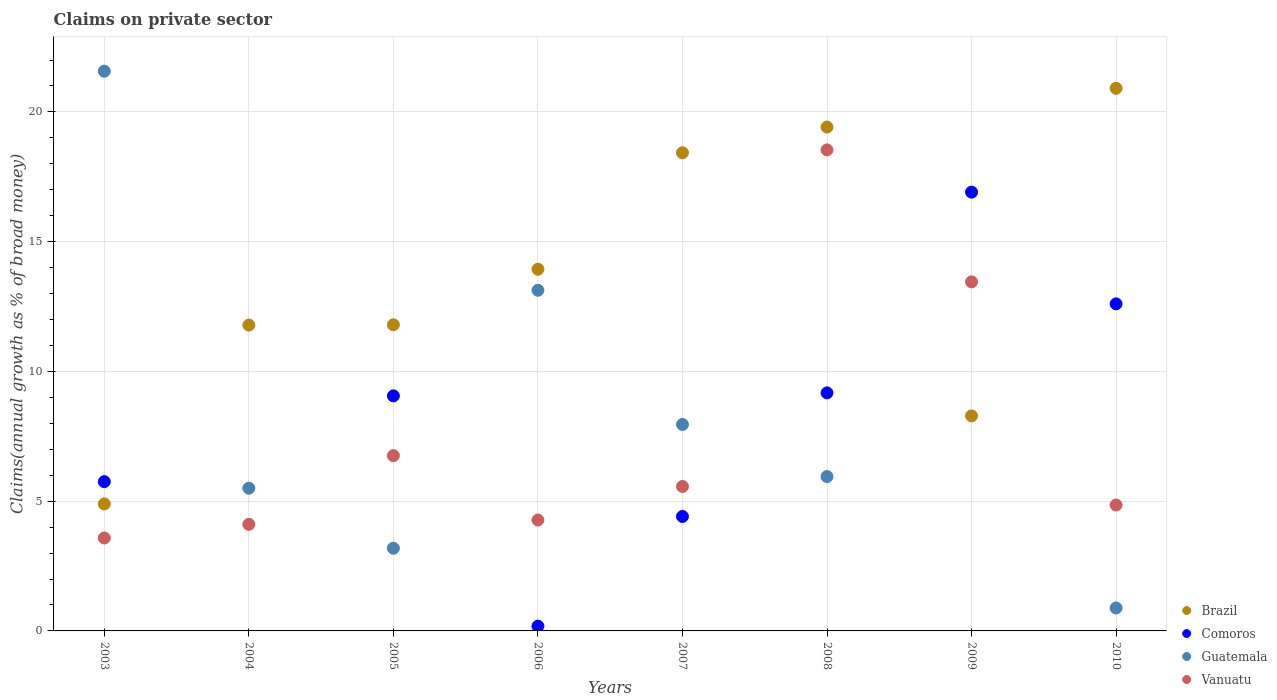Across all years, what is the maximum percentage of broad money claimed on private sector in Comoros?
Ensure brevity in your answer.  16.91. In which year was the percentage of broad money claimed on private sector in Brazil maximum?
Give a very brief answer. 2010. What is the total percentage of broad money claimed on private sector in Comoros in the graph?
Offer a very short reply. 58.09. What is the difference between the percentage of broad money claimed on private sector in Vanuatu in 2005 and that in 2009?
Your response must be concise. -6.7. What is the difference between the percentage of broad money claimed on private sector in Guatemala in 2004 and the percentage of broad money claimed on private sector in Vanuatu in 2009?
Provide a short and direct response. -7.95. What is the average percentage of broad money claimed on private sector in Comoros per year?
Offer a terse response. 7.26. In the year 2003, what is the difference between the percentage of broad money claimed on private sector in Guatemala and percentage of broad money claimed on private sector in Comoros?
Your response must be concise. 15.82. What is the ratio of the percentage of broad money claimed on private sector in Brazil in 2003 to that in 2006?
Make the answer very short. 0.35. What is the difference between the highest and the second highest percentage of broad money claimed on private sector in Comoros?
Provide a short and direct response. 4.3. What is the difference between the highest and the lowest percentage of broad money claimed on private sector in Guatemala?
Your answer should be compact. 21.57. In how many years, is the percentage of broad money claimed on private sector in Guatemala greater than the average percentage of broad money claimed on private sector in Guatemala taken over all years?
Your response must be concise. 3. Is the sum of the percentage of broad money claimed on private sector in Guatemala in 2007 and 2008 greater than the maximum percentage of broad money claimed on private sector in Vanuatu across all years?
Provide a succinct answer. No. Is it the case that in every year, the sum of the percentage of broad money claimed on private sector in Vanuatu and percentage of broad money claimed on private sector in Comoros  is greater than the sum of percentage of broad money claimed on private sector in Guatemala and percentage of broad money claimed on private sector in Brazil?
Offer a very short reply. No. Is it the case that in every year, the sum of the percentage of broad money claimed on private sector in Brazil and percentage of broad money claimed on private sector in Guatemala  is greater than the percentage of broad money claimed on private sector in Comoros?
Offer a terse response. No. Does the percentage of broad money claimed on private sector in Comoros monotonically increase over the years?
Keep it short and to the point. No. Is the percentage of broad money claimed on private sector in Brazil strictly less than the percentage of broad money claimed on private sector in Comoros over the years?
Your answer should be very brief. No. Are the values on the major ticks of Y-axis written in scientific E-notation?
Your answer should be compact. No. How many legend labels are there?
Offer a very short reply. 4. How are the legend labels stacked?
Your answer should be very brief. Vertical. What is the title of the graph?
Offer a terse response. Claims on private sector. Does "Netherlands" appear as one of the legend labels in the graph?
Your answer should be very brief. No. What is the label or title of the Y-axis?
Provide a short and direct response. Claims(annual growth as % of broad money). What is the Claims(annual growth as % of broad money) in Brazil in 2003?
Your answer should be compact. 4.89. What is the Claims(annual growth as % of broad money) of Comoros in 2003?
Offer a terse response. 5.75. What is the Claims(annual growth as % of broad money) of Guatemala in 2003?
Give a very brief answer. 21.57. What is the Claims(annual growth as % of broad money) of Vanuatu in 2003?
Provide a succinct answer. 3.58. What is the Claims(annual growth as % of broad money) of Brazil in 2004?
Your answer should be very brief. 11.79. What is the Claims(annual growth as % of broad money) of Comoros in 2004?
Make the answer very short. 0. What is the Claims(annual growth as % of broad money) in Guatemala in 2004?
Give a very brief answer. 5.5. What is the Claims(annual growth as % of broad money) of Vanuatu in 2004?
Give a very brief answer. 4.11. What is the Claims(annual growth as % of broad money) in Brazil in 2005?
Provide a short and direct response. 11.8. What is the Claims(annual growth as % of broad money) of Comoros in 2005?
Offer a terse response. 9.06. What is the Claims(annual growth as % of broad money) in Guatemala in 2005?
Your response must be concise. 3.19. What is the Claims(annual growth as % of broad money) in Vanuatu in 2005?
Your response must be concise. 6.75. What is the Claims(annual growth as % of broad money) of Brazil in 2006?
Provide a succinct answer. 13.94. What is the Claims(annual growth as % of broad money) in Comoros in 2006?
Your response must be concise. 0.18. What is the Claims(annual growth as % of broad money) of Guatemala in 2006?
Offer a terse response. 13.13. What is the Claims(annual growth as % of broad money) in Vanuatu in 2006?
Keep it short and to the point. 4.27. What is the Claims(annual growth as % of broad money) in Brazil in 2007?
Provide a short and direct response. 18.43. What is the Claims(annual growth as % of broad money) of Comoros in 2007?
Make the answer very short. 4.41. What is the Claims(annual growth as % of broad money) of Guatemala in 2007?
Provide a short and direct response. 7.96. What is the Claims(annual growth as % of broad money) of Vanuatu in 2007?
Ensure brevity in your answer.  5.57. What is the Claims(annual growth as % of broad money) in Brazil in 2008?
Your response must be concise. 19.42. What is the Claims(annual growth as % of broad money) of Comoros in 2008?
Your answer should be very brief. 9.17. What is the Claims(annual growth as % of broad money) in Guatemala in 2008?
Your answer should be compact. 5.95. What is the Claims(annual growth as % of broad money) of Vanuatu in 2008?
Give a very brief answer. 18.54. What is the Claims(annual growth as % of broad money) in Brazil in 2009?
Keep it short and to the point. 8.29. What is the Claims(annual growth as % of broad money) of Comoros in 2009?
Keep it short and to the point. 16.91. What is the Claims(annual growth as % of broad money) in Vanuatu in 2009?
Your answer should be compact. 13.45. What is the Claims(annual growth as % of broad money) of Brazil in 2010?
Make the answer very short. 20.91. What is the Claims(annual growth as % of broad money) of Comoros in 2010?
Keep it short and to the point. 12.6. What is the Claims(annual growth as % of broad money) of Guatemala in 2010?
Offer a very short reply. 0.88. What is the Claims(annual growth as % of broad money) in Vanuatu in 2010?
Your answer should be compact. 4.85. Across all years, what is the maximum Claims(annual growth as % of broad money) of Brazil?
Your response must be concise. 20.91. Across all years, what is the maximum Claims(annual growth as % of broad money) of Comoros?
Make the answer very short. 16.91. Across all years, what is the maximum Claims(annual growth as % of broad money) of Guatemala?
Keep it short and to the point. 21.57. Across all years, what is the maximum Claims(annual growth as % of broad money) of Vanuatu?
Ensure brevity in your answer.  18.54. Across all years, what is the minimum Claims(annual growth as % of broad money) of Brazil?
Give a very brief answer. 4.89. Across all years, what is the minimum Claims(annual growth as % of broad money) in Vanuatu?
Offer a terse response. 3.58. What is the total Claims(annual growth as % of broad money) of Brazil in the graph?
Your answer should be very brief. 109.45. What is the total Claims(annual growth as % of broad money) in Comoros in the graph?
Your answer should be compact. 58.09. What is the total Claims(annual growth as % of broad money) in Guatemala in the graph?
Offer a very short reply. 58.17. What is the total Claims(annual growth as % of broad money) of Vanuatu in the graph?
Ensure brevity in your answer.  61.12. What is the difference between the Claims(annual growth as % of broad money) of Brazil in 2003 and that in 2004?
Your answer should be very brief. -6.89. What is the difference between the Claims(annual growth as % of broad money) of Guatemala in 2003 and that in 2004?
Ensure brevity in your answer.  16.07. What is the difference between the Claims(annual growth as % of broad money) in Vanuatu in 2003 and that in 2004?
Offer a very short reply. -0.53. What is the difference between the Claims(annual growth as % of broad money) in Brazil in 2003 and that in 2005?
Your response must be concise. -6.9. What is the difference between the Claims(annual growth as % of broad money) in Comoros in 2003 and that in 2005?
Make the answer very short. -3.31. What is the difference between the Claims(annual growth as % of broad money) of Guatemala in 2003 and that in 2005?
Keep it short and to the point. 18.38. What is the difference between the Claims(annual growth as % of broad money) in Vanuatu in 2003 and that in 2005?
Provide a succinct answer. -3.17. What is the difference between the Claims(annual growth as % of broad money) in Brazil in 2003 and that in 2006?
Provide a short and direct response. -9.04. What is the difference between the Claims(annual growth as % of broad money) of Comoros in 2003 and that in 2006?
Offer a terse response. 5.57. What is the difference between the Claims(annual growth as % of broad money) of Guatemala in 2003 and that in 2006?
Ensure brevity in your answer.  8.44. What is the difference between the Claims(annual growth as % of broad money) of Vanuatu in 2003 and that in 2006?
Your response must be concise. -0.69. What is the difference between the Claims(annual growth as % of broad money) of Brazil in 2003 and that in 2007?
Make the answer very short. -13.53. What is the difference between the Claims(annual growth as % of broad money) in Comoros in 2003 and that in 2007?
Your response must be concise. 1.34. What is the difference between the Claims(annual growth as % of broad money) in Guatemala in 2003 and that in 2007?
Your answer should be very brief. 13.61. What is the difference between the Claims(annual growth as % of broad money) of Vanuatu in 2003 and that in 2007?
Offer a very short reply. -1.99. What is the difference between the Claims(annual growth as % of broad money) in Brazil in 2003 and that in 2008?
Give a very brief answer. -14.52. What is the difference between the Claims(annual growth as % of broad money) of Comoros in 2003 and that in 2008?
Provide a succinct answer. -3.42. What is the difference between the Claims(annual growth as % of broad money) of Guatemala in 2003 and that in 2008?
Your answer should be very brief. 15.62. What is the difference between the Claims(annual growth as % of broad money) of Vanuatu in 2003 and that in 2008?
Keep it short and to the point. -14.96. What is the difference between the Claims(annual growth as % of broad money) in Brazil in 2003 and that in 2009?
Keep it short and to the point. -3.39. What is the difference between the Claims(annual growth as % of broad money) in Comoros in 2003 and that in 2009?
Offer a very short reply. -11.16. What is the difference between the Claims(annual growth as % of broad money) of Vanuatu in 2003 and that in 2009?
Your answer should be very brief. -9.87. What is the difference between the Claims(annual growth as % of broad money) in Brazil in 2003 and that in 2010?
Keep it short and to the point. -16.01. What is the difference between the Claims(annual growth as % of broad money) in Comoros in 2003 and that in 2010?
Provide a short and direct response. -6.85. What is the difference between the Claims(annual growth as % of broad money) in Guatemala in 2003 and that in 2010?
Offer a terse response. 20.69. What is the difference between the Claims(annual growth as % of broad money) of Vanuatu in 2003 and that in 2010?
Your answer should be compact. -1.27. What is the difference between the Claims(annual growth as % of broad money) of Brazil in 2004 and that in 2005?
Make the answer very short. -0.01. What is the difference between the Claims(annual growth as % of broad money) in Guatemala in 2004 and that in 2005?
Ensure brevity in your answer.  2.31. What is the difference between the Claims(annual growth as % of broad money) of Vanuatu in 2004 and that in 2005?
Make the answer very short. -2.65. What is the difference between the Claims(annual growth as % of broad money) of Brazil in 2004 and that in 2006?
Give a very brief answer. -2.15. What is the difference between the Claims(annual growth as % of broad money) in Guatemala in 2004 and that in 2006?
Give a very brief answer. -7.63. What is the difference between the Claims(annual growth as % of broad money) of Vanuatu in 2004 and that in 2006?
Offer a terse response. -0.17. What is the difference between the Claims(annual growth as % of broad money) in Brazil in 2004 and that in 2007?
Offer a terse response. -6.64. What is the difference between the Claims(annual growth as % of broad money) in Guatemala in 2004 and that in 2007?
Offer a very short reply. -2.46. What is the difference between the Claims(annual growth as % of broad money) of Vanuatu in 2004 and that in 2007?
Provide a short and direct response. -1.46. What is the difference between the Claims(annual growth as % of broad money) of Brazil in 2004 and that in 2008?
Make the answer very short. -7.63. What is the difference between the Claims(annual growth as % of broad money) in Guatemala in 2004 and that in 2008?
Your answer should be compact. -0.45. What is the difference between the Claims(annual growth as % of broad money) in Vanuatu in 2004 and that in 2008?
Provide a short and direct response. -14.43. What is the difference between the Claims(annual growth as % of broad money) of Brazil in 2004 and that in 2009?
Your answer should be very brief. 3.5. What is the difference between the Claims(annual growth as % of broad money) in Vanuatu in 2004 and that in 2009?
Provide a succinct answer. -9.34. What is the difference between the Claims(annual growth as % of broad money) of Brazil in 2004 and that in 2010?
Provide a short and direct response. -9.12. What is the difference between the Claims(annual growth as % of broad money) of Guatemala in 2004 and that in 2010?
Offer a terse response. 4.61. What is the difference between the Claims(annual growth as % of broad money) of Vanuatu in 2004 and that in 2010?
Give a very brief answer. -0.75. What is the difference between the Claims(annual growth as % of broad money) in Brazil in 2005 and that in 2006?
Offer a terse response. -2.14. What is the difference between the Claims(annual growth as % of broad money) in Comoros in 2005 and that in 2006?
Make the answer very short. 8.87. What is the difference between the Claims(annual growth as % of broad money) of Guatemala in 2005 and that in 2006?
Your answer should be very brief. -9.94. What is the difference between the Claims(annual growth as % of broad money) in Vanuatu in 2005 and that in 2006?
Ensure brevity in your answer.  2.48. What is the difference between the Claims(annual growth as % of broad money) in Brazil in 2005 and that in 2007?
Offer a terse response. -6.63. What is the difference between the Claims(annual growth as % of broad money) in Comoros in 2005 and that in 2007?
Provide a succinct answer. 4.65. What is the difference between the Claims(annual growth as % of broad money) of Guatemala in 2005 and that in 2007?
Ensure brevity in your answer.  -4.77. What is the difference between the Claims(annual growth as % of broad money) of Vanuatu in 2005 and that in 2007?
Your answer should be compact. 1.19. What is the difference between the Claims(annual growth as % of broad money) of Brazil in 2005 and that in 2008?
Your answer should be compact. -7.62. What is the difference between the Claims(annual growth as % of broad money) in Comoros in 2005 and that in 2008?
Offer a terse response. -0.12. What is the difference between the Claims(annual growth as % of broad money) of Guatemala in 2005 and that in 2008?
Offer a very short reply. -2.76. What is the difference between the Claims(annual growth as % of broad money) of Vanuatu in 2005 and that in 2008?
Offer a very short reply. -11.78. What is the difference between the Claims(annual growth as % of broad money) of Brazil in 2005 and that in 2009?
Your answer should be compact. 3.51. What is the difference between the Claims(annual growth as % of broad money) in Comoros in 2005 and that in 2009?
Provide a succinct answer. -7.85. What is the difference between the Claims(annual growth as % of broad money) of Vanuatu in 2005 and that in 2009?
Provide a succinct answer. -6.7. What is the difference between the Claims(annual growth as % of broad money) in Brazil in 2005 and that in 2010?
Give a very brief answer. -9.11. What is the difference between the Claims(annual growth as % of broad money) of Comoros in 2005 and that in 2010?
Make the answer very short. -3.55. What is the difference between the Claims(annual growth as % of broad money) in Guatemala in 2005 and that in 2010?
Provide a short and direct response. 2.3. What is the difference between the Claims(annual growth as % of broad money) of Vanuatu in 2005 and that in 2010?
Provide a short and direct response. 1.9. What is the difference between the Claims(annual growth as % of broad money) in Brazil in 2006 and that in 2007?
Offer a very short reply. -4.49. What is the difference between the Claims(annual growth as % of broad money) in Comoros in 2006 and that in 2007?
Give a very brief answer. -4.23. What is the difference between the Claims(annual growth as % of broad money) of Guatemala in 2006 and that in 2007?
Keep it short and to the point. 5.17. What is the difference between the Claims(annual growth as % of broad money) of Vanuatu in 2006 and that in 2007?
Provide a short and direct response. -1.29. What is the difference between the Claims(annual growth as % of broad money) of Brazil in 2006 and that in 2008?
Ensure brevity in your answer.  -5.48. What is the difference between the Claims(annual growth as % of broad money) of Comoros in 2006 and that in 2008?
Your answer should be compact. -8.99. What is the difference between the Claims(annual growth as % of broad money) in Guatemala in 2006 and that in 2008?
Offer a very short reply. 7.18. What is the difference between the Claims(annual growth as % of broad money) of Vanuatu in 2006 and that in 2008?
Make the answer very short. -14.26. What is the difference between the Claims(annual growth as % of broad money) in Brazil in 2006 and that in 2009?
Your answer should be compact. 5.65. What is the difference between the Claims(annual growth as % of broad money) in Comoros in 2006 and that in 2009?
Keep it short and to the point. -16.72. What is the difference between the Claims(annual growth as % of broad money) of Vanuatu in 2006 and that in 2009?
Keep it short and to the point. -9.18. What is the difference between the Claims(annual growth as % of broad money) of Brazil in 2006 and that in 2010?
Offer a very short reply. -6.97. What is the difference between the Claims(annual growth as % of broad money) in Comoros in 2006 and that in 2010?
Your answer should be compact. -12.42. What is the difference between the Claims(annual growth as % of broad money) of Guatemala in 2006 and that in 2010?
Ensure brevity in your answer.  12.24. What is the difference between the Claims(annual growth as % of broad money) of Vanuatu in 2006 and that in 2010?
Offer a very short reply. -0.58. What is the difference between the Claims(annual growth as % of broad money) of Brazil in 2007 and that in 2008?
Provide a succinct answer. -0.99. What is the difference between the Claims(annual growth as % of broad money) in Comoros in 2007 and that in 2008?
Your response must be concise. -4.76. What is the difference between the Claims(annual growth as % of broad money) in Guatemala in 2007 and that in 2008?
Provide a succinct answer. 2.01. What is the difference between the Claims(annual growth as % of broad money) in Vanuatu in 2007 and that in 2008?
Make the answer very short. -12.97. What is the difference between the Claims(annual growth as % of broad money) in Brazil in 2007 and that in 2009?
Keep it short and to the point. 10.14. What is the difference between the Claims(annual growth as % of broad money) of Comoros in 2007 and that in 2009?
Provide a short and direct response. -12.5. What is the difference between the Claims(annual growth as % of broad money) in Vanuatu in 2007 and that in 2009?
Ensure brevity in your answer.  -7.88. What is the difference between the Claims(annual growth as % of broad money) in Brazil in 2007 and that in 2010?
Offer a very short reply. -2.48. What is the difference between the Claims(annual growth as % of broad money) of Comoros in 2007 and that in 2010?
Keep it short and to the point. -8.19. What is the difference between the Claims(annual growth as % of broad money) of Guatemala in 2007 and that in 2010?
Provide a succinct answer. 7.07. What is the difference between the Claims(annual growth as % of broad money) in Vanuatu in 2007 and that in 2010?
Your response must be concise. 0.71. What is the difference between the Claims(annual growth as % of broad money) of Brazil in 2008 and that in 2009?
Provide a short and direct response. 11.13. What is the difference between the Claims(annual growth as % of broad money) of Comoros in 2008 and that in 2009?
Ensure brevity in your answer.  -7.74. What is the difference between the Claims(annual growth as % of broad money) of Vanuatu in 2008 and that in 2009?
Make the answer very short. 5.09. What is the difference between the Claims(annual growth as % of broad money) of Brazil in 2008 and that in 2010?
Your response must be concise. -1.49. What is the difference between the Claims(annual growth as % of broad money) of Comoros in 2008 and that in 2010?
Keep it short and to the point. -3.43. What is the difference between the Claims(annual growth as % of broad money) in Guatemala in 2008 and that in 2010?
Give a very brief answer. 5.06. What is the difference between the Claims(annual growth as % of broad money) in Vanuatu in 2008 and that in 2010?
Your answer should be compact. 13.68. What is the difference between the Claims(annual growth as % of broad money) in Brazil in 2009 and that in 2010?
Provide a succinct answer. -12.62. What is the difference between the Claims(annual growth as % of broad money) of Comoros in 2009 and that in 2010?
Provide a succinct answer. 4.3. What is the difference between the Claims(annual growth as % of broad money) of Vanuatu in 2009 and that in 2010?
Your response must be concise. 8.6. What is the difference between the Claims(annual growth as % of broad money) in Brazil in 2003 and the Claims(annual growth as % of broad money) in Guatemala in 2004?
Keep it short and to the point. -0.6. What is the difference between the Claims(annual growth as % of broad money) in Brazil in 2003 and the Claims(annual growth as % of broad money) in Vanuatu in 2004?
Your response must be concise. 0.79. What is the difference between the Claims(annual growth as % of broad money) in Comoros in 2003 and the Claims(annual growth as % of broad money) in Guatemala in 2004?
Offer a very short reply. 0.25. What is the difference between the Claims(annual growth as % of broad money) in Comoros in 2003 and the Claims(annual growth as % of broad money) in Vanuatu in 2004?
Offer a very short reply. 1.64. What is the difference between the Claims(annual growth as % of broad money) of Guatemala in 2003 and the Claims(annual growth as % of broad money) of Vanuatu in 2004?
Your answer should be very brief. 17.46. What is the difference between the Claims(annual growth as % of broad money) of Brazil in 2003 and the Claims(annual growth as % of broad money) of Comoros in 2005?
Your answer should be compact. -4.16. What is the difference between the Claims(annual growth as % of broad money) of Brazil in 2003 and the Claims(annual growth as % of broad money) of Guatemala in 2005?
Your response must be concise. 1.71. What is the difference between the Claims(annual growth as % of broad money) in Brazil in 2003 and the Claims(annual growth as % of broad money) in Vanuatu in 2005?
Ensure brevity in your answer.  -1.86. What is the difference between the Claims(annual growth as % of broad money) in Comoros in 2003 and the Claims(annual growth as % of broad money) in Guatemala in 2005?
Offer a very short reply. 2.56. What is the difference between the Claims(annual growth as % of broad money) in Comoros in 2003 and the Claims(annual growth as % of broad money) in Vanuatu in 2005?
Your response must be concise. -1. What is the difference between the Claims(annual growth as % of broad money) of Guatemala in 2003 and the Claims(annual growth as % of broad money) of Vanuatu in 2005?
Provide a short and direct response. 14.82. What is the difference between the Claims(annual growth as % of broad money) in Brazil in 2003 and the Claims(annual growth as % of broad money) in Comoros in 2006?
Your answer should be compact. 4.71. What is the difference between the Claims(annual growth as % of broad money) in Brazil in 2003 and the Claims(annual growth as % of broad money) in Guatemala in 2006?
Offer a very short reply. -8.23. What is the difference between the Claims(annual growth as % of broad money) in Brazil in 2003 and the Claims(annual growth as % of broad money) in Vanuatu in 2006?
Offer a very short reply. 0.62. What is the difference between the Claims(annual growth as % of broad money) of Comoros in 2003 and the Claims(annual growth as % of broad money) of Guatemala in 2006?
Offer a terse response. -7.38. What is the difference between the Claims(annual growth as % of broad money) of Comoros in 2003 and the Claims(annual growth as % of broad money) of Vanuatu in 2006?
Offer a terse response. 1.48. What is the difference between the Claims(annual growth as % of broad money) of Guatemala in 2003 and the Claims(annual growth as % of broad money) of Vanuatu in 2006?
Provide a short and direct response. 17.3. What is the difference between the Claims(annual growth as % of broad money) in Brazil in 2003 and the Claims(annual growth as % of broad money) in Comoros in 2007?
Provide a short and direct response. 0.48. What is the difference between the Claims(annual growth as % of broad money) of Brazil in 2003 and the Claims(annual growth as % of broad money) of Guatemala in 2007?
Your response must be concise. -3.06. What is the difference between the Claims(annual growth as % of broad money) in Brazil in 2003 and the Claims(annual growth as % of broad money) in Vanuatu in 2007?
Keep it short and to the point. -0.67. What is the difference between the Claims(annual growth as % of broad money) of Comoros in 2003 and the Claims(annual growth as % of broad money) of Guatemala in 2007?
Provide a short and direct response. -2.2. What is the difference between the Claims(annual growth as % of broad money) of Comoros in 2003 and the Claims(annual growth as % of broad money) of Vanuatu in 2007?
Keep it short and to the point. 0.19. What is the difference between the Claims(annual growth as % of broad money) of Guatemala in 2003 and the Claims(annual growth as % of broad money) of Vanuatu in 2007?
Provide a succinct answer. 16. What is the difference between the Claims(annual growth as % of broad money) in Brazil in 2003 and the Claims(annual growth as % of broad money) in Comoros in 2008?
Provide a short and direct response. -4.28. What is the difference between the Claims(annual growth as % of broad money) in Brazil in 2003 and the Claims(annual growth as % of broad money) in Guatemala in 2008?
Give a very brief answer. -1.05. What is the difference between the Claims(annual growth as % of broad money) in Brazil in 2003 and the Claims(annual growth as % of broad money) in Vanuatu in 2008?
Your answer should be compact. -13.64. What is the difference between the Claims(annual growth as % of broad money) of Comoros in 2003 and the Claims(annual growth as % of broad money) of Guatemala in 2008?
Give a very brief answer. -0.2. What is the difference between the Claims(annual growth as % of broad money) of Comoros in 2003 and the Claims(annual growth as % of broad money) of Vanuatu in 2008?
Your answer should be very brief. -12.79. What is the difference between the Claims(annual growth as % of broad money) of Guatemala in 2003 and the Claims(annual growth as % of broad money) of Vanuatu in 2008?
Give a very brief answer. 3.03. What is the difference between the Claims(annual growth as % of broad money) of Brazil in 2003 and the Claims(annual growth as % of broad money) of Comoros in 2009?
Provide a succinct answer. -12.01. What is the difference between the Claims(annual growth as % of broad money) in Brazil in 2003 and the Claims(annual growth as % of broad money) in Vanuatu in 2009?
Your response must be concise. -8.56. What is the difference between the Claims(annual growth as % of broad money) of Comoros in 2003 and the Claims(annual growth as % of broad money) of Vanuatu in 2009?
Your response must be concise. -7.7. What is the difference between the Claims(annual growth as % of broad money) of Guatemala in 2003 and the Claims(annual growth as % of broad money) of Vanuatu in 2009?
Provide a succinct answer. 8.12. What is the difference between the Claims(annual growth as % of broad money) in Brazil in 2003 and the Claims(annual growth as % of broad money) in Comoros in 2010?
Your answer should be compact. -7.71. What is the difference between the Claims(annual growth as % of broad money) of Brazil in 2003 and the Claims(annual growth as % of broad money) of Guatemala in 2010?
Keep it short and to the point. 4.01. What is the difference between the Claims(annual growth as % of broad money) in Brazil in 2003 and the Claims(annual growth as % of broad money) in Vanuatu in 2010?
Provide a succinct answer. 0.04. What is the difference between the Claims(annual growth as % of broad money) in Comoros in 2003 and the Claims(annual growth as % of broad money) in Guatemala in 2010?
Ensure brevity in your answer.  4.87. What is the difference between the Claims(annual growth as % of broad money) of Comoros in 2003 and the Claims(annual growth as % of broad money) of Vanuatu in 2010?
Make the answer very short. 0.9. What is the difference between the Claims(annual growth as % of broad money) in Guatemala in 2003 and the Claims(annual growth as % of broad money) in Vanuatu in 2010?
Provide a succinct answer. 16.72. What is the difference between the Claims(annual growth as % of broad money) of Brazil in 2004 and the Claims(annual growth as % of broad money) of Comoros in 2005?
Provide a short and direct response. 2.73. What is the difference between the Claims(annual growth as % of broad money) in Brazil in 2004 and the Claims(annual growth as % of broad money) in Guatemala in 2005?
Provide a succinct answer. 8.6. What is the difference between the Claims(annual growth as % of broad money) in Brazil in 2004 and the Claims(annual growth as % of broad money) in Vanuatu in 2005?
Offer a terse response. 5.03. What is the difference between the Claims(annual growth as % of broad money) in Guatemala in 2004 and the Claims(annual growth as % of broad money) in Vanuatu in 2005?
Provide a succinct answer. -1.25. What is the difference between the Claims(annual growth as % of broad money) of Brazil in 2004 and the Claims(annual growth as % of broad money) of Comoros in 2006?
Give a very brief answer. 11.6. What is the difference between the Claims(annual growth as % of broad money) in Brazil in 2004 and the Claims(annual growth as % of broad money) in Guatemala in 2006?
Provide a succinct answer. -1.34. What is the difference between the Claims(annual growth as % of broad money) in Brazil in 2004 and the Claims(annual growth as % of broad money) in Vanuatu in 2006?
Your answer should be very brief. 7.51. What is the difference between the Claims(annual growth as % of broad money) of Guatemala in 2004 and the Claims(annual growth as % of broad money) of Vanuatu in 2006?
Your answer should be very brief. 1.23. What is the difference between the Claims(annual growth as % of broad money) in Brazil in 2004 and the Claims(annual growth as % of broad money) in Comoros in 2007?
Your answer should be very brief. 7.38. What is the difference between the Claims(annual growth as % of broad money) of Brazil in 2004 and the Claims(annual growth as % of broad money) of Guatemala in 2007?
Offer a terse response. 3.83. What is the difference between the Claims(annual growth as % of broad money) of Brazil in 2004 and the Claims(annual growth as % of broad money) of Vanuatu in 2007?
Your answer should be compact. 6.22. What is the difference between the Claims(annual growth as % of broad money) in Guatemala in 2004 and the Claims(annual growth as % of broad money) in Vanuatu in 2007?
Your response must be concise. -0.07. What is the difference between the Claims(annual growth as % of broad money) in Brazil in 2004 and the Claims(annual growth as % of broad money) in Comoros in 2008?
Your answer should be very brief. 2.61. What is the difference between the Claims(annual growth as % of broad money) of Brazil in 2004 and the Claims(annual growth as % of broad money) of Guatemala in 2008?
Give a very brief answer. 5.84. What is the difference between the Claims(annual growth as % of broad money) of Brazil in 2004 and the Claims(annual growth as % of broad money) of Vanuatu in 2008?
Offer a terse response. -6.75. What is the difference between the Claims(annual growth as % of broad money) of Guatemala in 2004 and the Claims(annual growth as % of broad money) of Vanuatu in 2008?
Provide a succinct answer. -13.04. What is the difference between the Claims(annual growth as % of broad money) in Brazil in 2004 and the Claims(annual growth as % of broad money) in Comoros in 2009?
Make the answer very short. -5.12. What is the difference between the Claims(annual growth as % of broad money) in Brazil in 2004 and the Claims(annual growth as % of broad money) in Vanuatu in 2009?
Keep it short and to the point. -1.66. What is the difference between the Claims(annual growth as % of broad money) of Guatemala in 2004 and the Claims(annual growth as % of broad money) of Vanuatu in 2009?
Ensure brevity in your answer.  -7.95. What is the difference between the Claims(annual growth as % of broad money) of Brazil in 2004 and the Claims(annual growth as % of broad money) of Comoros in 2010?
Ensure brevity in your answer.  -0.82. What is the difference between the Claims(annual growth as % of broad money) of Brazil in 2004 and the Claims(annual growth as % of broad money) of Guatemala in 2010?
Provide a succinct answer. 10.9. What is the difference between the Claims(annual growth as % of broad money) in Brazil in 2004 and the Claims(annual growth as % of broad money) in Vanuatu in 2010?
Give a very brief answer. 6.93. What is the difference between the Claims(annual growth as % of broad money) of Guatemala in 2004 and the Claims(annual growth as % of broad money) of Vanuatu in 2010?
Give a very brief answer. 0.65. What is the difference between the Claims(annual growth as % of broad money) in Brazil in 2005 and the Claims(annual growth as % of broad money) in Comoros in 2006?
Keep it short and to the point. 11.61. What is the difference between the Claims(annual growth as % of broad money) in Brazil in 2005 and the Claims(annual growth as % of broad money) in Guatemala in 2006?
Keep it short and to the point. -1.33. What is the difference between the Claims(annual growth as % of broad money) in Brazil in 2005 and the Claims(annual growth as % of broad money) in Vanuatu in 2006?
Ensure brevity in your answer.  7.52. What is the difference between the Claims(annual growth as % of broad money) of Comoros in 2005 and the Claims(annual growth as % of broad money) of Guatemala in 2006?
Offer a very short reply. -4.07. What is the difference between the Claims(annual growth as % of broad money) in Comoros in 2005 and the Claims(annual growth as % of broad money) in Vanuatu in 2006?
Make the answer very short. 4.78. What is the difference between the Claims(annual growth as % of broad money) of Guatemala in 2005 and the Claims(annual growth as % of broad money) of Vanuatu in 2006?
Make the answer very short. -1.09. What is the difference between the Claims(annual growth as % of broad money) in Brazil in 2005 and the Claims(annual growth as % of broad money) in Comoros in 2007?
Offer a very short reply. 7.39. What is the difference between the Claims(annual growth as % of broad money) in Brazil in 2005 and the Claims(annual growth as % of broad money) in Guatemala in 2007?
Offer a terse response. 3.84. What is the difference between the Claims(annual growth as % of broad money) of Brazil in 2005 and the Claims(annual growth as % of broad money) of Vanuatu in 2007?
Offer a very short reply. 6.23. What is the difference between the Claims(annual growth as % of broad money) in Comoros in 2005 and the Claims(annual growth as % of broad money) in Guatemala in 2007?
Offer a very short reply. 1.1. What is the difference between the Claims(annual growth as % of broad money) of Comoros in 2005 and the Claims(annual growth as % of broad money) of Vanuatu in 2007?
Make the answer very short. 3.49. What is the difference between the Claims(annual growth as % of broad money) of Guatemala in 2005 and the Claims(annual growth as % of broad money) of Vanuatu in 2007?
Give a very brief answer. -2.38. What is the difference between the Claims(annual growth as % of broad money) of Brazil in 2005 and the Claims(annual growth as % of broad money) of Comoros in 2008?
Your response must be concise. 2.62. What is the difference between the Claims(annual growth as % of broad money) of Brazil in 2005 and the Claims(annual growth as % of broad money) of Guatemala in 2008?
Your answer should be very brief. 5.85. What is the difference between the Claims(annual growth as % of broad money) in Brazil in 2005 and the Claims(annual growth as % of broad money) in Vanuatu in 2008?
Keep it short and to the point. -6.74. What is the difference between the Claims(annual growth as % of broad money) of Comoros in 2005 and the Claims(annual growth as % of broad money) of Guatemala in 2008?
Provide a short and direct response. 3.11. What is the difference between the Claims(annual growth as % of broad money) of Comoros in 2005 and the Claims(annual growth as % of broad money) of Vanuatu in 2008?
Offer a very short reply. -9.48. What is the difference between the Claims(annual growth as % of broad money) of Guatemala in 2005 and the Claims(annual growth as % of broad money) of Vanuatu in 2008?
Your response must be concise. -15.35. What is the difference between the Claims(annual growth as % of broad money) of Brazil in 2005 and the Claims(annual growth as % of broad money) of Comoros in 2009?
Make the answer very short. -5.11. What is the difference between the Claims(annual growth as % of broad money) of Brazil in 2005 and the Claims(annual growth as % of broad money) of Vanuatu in 2009?
Offer a very short reply. -1.65. What is the difference between the Claims(annual growth as % of broad money) in Comoros in 2005 and the Claims(annual growth as % of broad money) in Vanuatu in 2009?
Your answer should be compact. -4.39. What is the difference between the Claims(annual growth as % of broad money) of Guatemala in 2005 and the Claims(annual growth as % of broad money) of Vanuatu in 2009?
Your answer should be very brief. -10.26. What is the difference between the Claims(annual growth as % of broad money) in Brazil in 2005 and the Claims(annual growth as % of broad money) in Comoros in 2010?
Give a very brief answer. -0.81. What is the difference between the Claims(annual growth as % of broad money) of Brazil in 2005 and the Claims(annual growth as % of broad money) of Guatemala in 2010?
Make the answer very short. 10.91. What is the difference between the Claims(annual growth as % of broad money) of Brazil in 2005 and the Claims(annual growth as % of broad money) of Vanuatu in 2010?
Offer a terse response. 6.95. What is the difference between the Claims(annual growth as % of broad money) in Comoros in 2005 and the Claims(annual growth as % of broad money) in Guatemala in 2010?
Your answer should be very brief. 8.17. What is the difference between the Claims(annual growth as % of broad money) of Comoros in 2005 and the Claims(annual growth as % of broad money) of Vanuatu in 2010?
Keep it short and to the point. 4.21. What is the difference between the Claims(annual growth as % of broad money) of Guatemala in 2005 and the Claims(annual growth as % of broad money) of Vanuatu in 2010?
Your answer should be compact. -1.67. What is the difference between the Claims(annual growth as % of broad money) of Brazil in 2006 and the Claims(annual growth as % of broad money) of Comoros in 2007?
Give a very brief answer. 9.53. What is the difference between the Claims(annual growth as % of broad money) in Brazil in 2006 and the Claims(annual growth as % of broad money) in Guatemala in 2007?
Your response must be concise. 5.98. What is the difference between the Claims(annual growth as % of broad money) in Brazil in 2006 and the Claims(annual growth as % of broad money) in Vanuatu in 2007?
Your answer should be compact. 8.37. What is the difference between the Claims(annual growth as % of broad money) in Comoros in 2006 and the Claims(annual growth as % of broad money) in Guatemala in 2007?
Your response must be concise. -7.77. What is the difference between the Claims(annual growth as % of broad money) in Comoros in 2006 and the Claims(annual growth as % of broad money) in Vanuatu in 2007?
Offer a terse response. -5.38. What is the difference between the Claims(annual growth as % of broad money) in Guatemala in 2006 and the Claims(annual growth as % of broad money) in Vanuatu in 2007?
Your answer should be compact. 7.56. What is the difference between the Claims(annual growth as % of broad money) in Brazil in 2006 and the Claims(annual growth as % of broad money) in Comoros in 2008?
Your answer should be very brief. 4.76. What is the difference between the Claims(annual growth as % of broad money) of Brazil in 2006 and the Claims(annual growth as % of broad money) of Guatemala in 2008?
Keep it short and to the point. 7.99. What is the difference between the Claims(annual growth as % of broad money) in Brazil in 2006 and the Claims(annual growth as % of broad money) in Vanuatu in 2008?
Offer a terse response. -4.6. What is the difference between the Claims(annual growth as % of broad money) in Comoros in 2006 and the Claims(annual growth as % of broad money) in Guatemala in 2008?
Ensure brevity in your answer.  -5.76. What is the difference between the Claims(annual growth as % of broad money) of Comoros in 2006 and the Claims(annual growth as % of broad money) of Vanuatu in 2008?
Offer a very short reply. -18.35. What is the difference between the Claims(annual growth as % of broad money) of Guatemala in 2006 and the Claims(annual growth as % of broad money) of Vanuatu in 2008?
Your response must be concise. -5.41. What is the difference between the Claims(annual growth as % of broad money) in Brazil in 2006 and the Claims(annual growth as % of broad money) in Comoros in 2009?
Make the answer very short. -2.97. What is the difference between the Claims(annual growth as % of broad money) in Brazil in 2006 and the Claims(annual growth as % of broad money) in Vanuatu in 2009?
Keep it short and to the point. 0.49. What is the difference between the Claims(annual growth as % of broad money) in Comoros in 2006 and the Claims(annual growth as % of broad money) in Vanuatu in 2009?
Your response must be concise. -13.27. What is the difference between the Claims(annual growth as % of broad money) in Guatemala in 2006 and the Claims(annual growth as % of broad money) in Vanuatu in 2009?
Provide a succinct answer. -0.32. What is the difference between the Claims(annual growth as % of broad money) of Brazil in 2006 and the Claims(annual growth as % of broad money) of Comoros in 2010?
Provide a succinct answer. 1.33. What is the difference between the Claims(annual growth as % of broad money) in Brazil in 2006 and the Claims(annual growth as % of broad money) in Guatemala in 2010?
Keep it short and to the point. 13.05. What is the difference between the Claims(annual growth as % of broad money) of Brazil in 2006 and the Claims(annual growth as % of broad money) of Vanuatu in 2010?
Keep it short and to the point. 9.09. What is the difference between the Claims(annual growth as % of broad money) of Comoros in 2006 and the Claims(annual growth as % of broad money) of Guatemala in 2010?
Provide a short and direct response. -0.7. What is the difference between the Claims(annual growth as % of broad money) in Comoros in 2006 and the Claims(annual growth as % of broad money) in Vanuatu in 2010?
Offer a very short reply. -4.67. What is the difference between the Claims(annual growth as % of broad money) of Guatemala in 2006 and the Claims(annual growth as % of broad money) of Vanuatu in 2010?
Your response must be concise. 8.27. What is the difference between the Claims(annual growth as % of broad money) of Brazil in 2007 and the Claims(annual growth as % of broad money) of Comoros in 2008?
Your answer should be very brief. 9.25. What is the difference between the Claims(annual growth as % of broad money) of Brazil in 2007 and the Claims(annual growth as % of broad money) of Guatemala in 2008?
Provide a short and direct response. 12.48. What is the difference between the Claims(annual growth as % of broad money) in Brazil in 2007 and the Claims(annual growth as % of broad money) in Vanuatu in 2008?
Offer a terse response. -0.11. What is the difference between the Claims(annual growth as % of broad money) of Comoros in 2007 and the Claims(annual growth as % of broad money) of Guatemala in 2008?
Offer a very short reply. -1.54. What is the difference between the Claims(annual growth as % of broad money) in Comoros in 2007 and the Claims(annual growth as % of broad money) in Vanuatu in 2008?
Make the answer very short. -14.13. What is the difference between the Claims(annual growth as % of broad money) in Guatemala in 2007 and the Claims(annual growth as % of broad money) in Vanuatu in 2008?
Offer a terse response. -10.58. What is the difference between the Claims(annual growth as % of broad money) of Brazil in 2007 and the Claims(annual growth as % of broad money) of Comoros in 2009?
Provide a succinct answer. 1.52. What is the difference between the Claims(annual growth as % of broad money) in Brazil in 2007 and the Claims(annual growth as % of broad money) in Vanuatu in 2009?
Provide a short and direct response. 4.98. What is the difference between the Claims(annual growth as % of broad money) of Comoros in 2007 and the Claims(annual growth as % of broad money) of Vanuatu in 2009?
Offer a very short reply. -9.04. What is the difference between the Claims(annual growth as % of broad money) of Guatemala in 2007 and the Claims(annual growth as % of broad money) of Vanuatu in 2009?
Provide a short and direct response. -5.5. What is the difference between the Claims(annual growth as % of broad money) of Brazil in 2007 and the Claims(annual growth as % of broad money) of Comoros in 2010?
Your answer should be very brief. 5.82. What is the difference between the Claims(annual growth as % of broad money) in Brazil in 2007 and the Claims(annual growth as % of broad money) in Guatemala in 2010?
Keep it short and to the point. 17.54. What is the difference between the Claims(annual growth as % of broad money) of Brazil in 2007 and the Claims(annual growth as % of broad money) of Vanuatu in 2010?
Give a very brief answer. 13.57. What is the difference between the Claims(annual growth as % of broad money) in Comoros in 2007 and the Claims(annual growth as % of broad money) in Guatemala in 2010?
Offer a very short reply. 3.53. What is the difference between the Claims(annual growth as % of broad money) of Comoros in 2007 and the Claims(annual growth as % of broad money) of Vanuatu in 2010?
Offer a terse response. -0.44. What is the difference between the Claims(annual growth as % of broad money) in Guatemala in 2007 and the Claims(annual growth as % of broad money) in Vanuatu in 2010?
Make the answer very short. 3.1. What is the difference between the Claims(annual growth as % of broad money) of Brazil in 2008 and the Claims(annual growth as % of broad money) of Comoros in 2009?
Your answer should be very brief. 2.51. What is the difference between the Claims(annual growth as % of broad money) in Brazil in 2008 and the Claims(annual growth as % of broad money) in Vanuatu in 2009?
Give a very brief answer. 5.97. What is the difference between the Claims(annual growth as % of broad money) of Comoros in 2008 and the Claims(annual growth as % of broad money) of Vanuatu in 2009?
Offer a very short reply. -4.28. What is the difference between the Claims(annual growth as % of broad money) of Guatemala in 2008 and the Claims(annual growth as % of broad money) of Vanuatu in 2009?
Provide a succinct answer. -7.5. What is the difference between the Claims(annual growth as % of broad money) of Brazil in 2008 and the Claims(annual growth as % of broad money) of Comoros in 2010?
Your answer should be compact. 6.81. What is the difference between the Claims(annual growth as % of broad money) of Brazil in 2008 and the Claims(annual growth as % of broad money) of Guatemala in 2010?
Give a very brief answer. 18.53. What is the difference between the Claims(annual growth as % of broad money) of Brazil in 2008 and the Claims(annual growth as % of broad money) of Vanuatu in 2010?
Provide a short and direct response. 14.56. What is the difference between the Claims(annual growth as % of broad money) of Comoros in 2008 and the Claims(annual growth as % of broad money) of Guatemala in 2010?
Make the answer very short. 8.29. What is the difference between the Claims(annual growth as % of broad money) of Comoros in 2008 and the Claims(annual growth as % of broad money) of Vanuatu in 2010?
Ensure brevity in your answer.  4.32. What is the difference between the Claims(annual growth as % of broad money) of Guatemala in 2008 and the Claims(annual growth as % of broad money) of Vanuatu in 2010?
Your response must be concise. 1.1. What is the difference between the Claims(annual growth as % of broad money) of Brazil in 2009 and the Claims(annual growth as % of broad money) of Comoros in 2010?
Provide a short and direct response. -4.32. What is the difference between the Claims(annual growth as % of broad money) of Brazil in 2009 and the Claims(annual growth as % of broad money) of Guatemala in 2010?
Make the answer very short. 7.4. What is the difference between the Claims(annual growth as % of broad money) of Brazil in 2009 and the Claims(annual growth as % of broad money) of Vanuatu in 2010?
Give a very brief answer. 3.44. What is the difference between the Claims(annual growth as % of broad money) of Comoros in 2009 and the Claims(annual growth as % of broad money) of Guatemala in 2010?
Offer a very short reply. 16.02. What is the difference between the Claims(annual growth as % of broad money) of Comoros in 2009 and the Claims(annual growth as % of broad money) of Vanuatu in 2010?
Your answer should be very brief. 12.06. What is the average Claims(annual growth as % of broad money) of Brazil per year?
Provide a short and direct response. 13.68. What is the average Claims(annual growth as % of broad money) in Comoros per year?
Give a very brief answer. 7.26. What is the average Claims(annual growth as % of broad money) in Guatemala per year?
Your answer should be very brief. 7.27. What is the average Claims(annual growth as % of broad money) in Vanuatu per year?
Provide a succinct answer. 7.64. In the year 2003, what is the difference between the Claims(annual growth as % of broad money) in Brazil and Claims(annual growth as % of broad money) in Comoros?
Provide a short and direct response. -0.86. In the year 2003, what is the difference between the Claims(annual growth as % of broad money) of Brazil and Claims(annual growth as % of broad money) of Guatemala?
Give a very brief answer. -16.68. In the year 2003, what is the difference between the Claims(annual growth as % of broad money) in Brazil and Claims(annual growth as % of broad money) in Vanuatu?
Your response must be concise. 1.31. In the year 2003, what is the difference between the Claims(annual growth as % of broad money) in Comoros and Claims(annual growth as % of broad money) in Guatemala?
Your response must be concise. -15.82. In the year 2003, what is the difference between the Claims(annual growth as % of broad money) in Comoros and Claims(annual growth as % of broad money) in Vanuatu?
Ensure brevity in your answer.  2.17. In the year 2003, what is the difference between the Claims(annual growth as % of broad money) in Guatemala and Claims(annual growth as % of broad money) in Vanuatu?
Ensure brevity in your answer.  17.99. In the year 2004, what is the difference between the Claims(annual growth as % of broad money) in Brazil and Claims(annual growth as % of broad money) in Guatemala?
Offer a very short reply. 6.29. In the year 2004, what is the difference between the Claims(annual growth as % of broad money) in Brazil and Claims(annual growth as % of broad money) in Vanuatu?
Your response must be concise. 7.68. In the year 2004, what is the difference between the Claims(annual growth as % of broad money) of Guatemala and Claims(annual growth as % of broad money) of Vanuatu?
Your answer should be compact. 1.39. In the year 2005, what is the difference between the Claims(annual growth as % of broad money) of Brazil and Claims(annual growth as % of broad money) of Comoros?
Your response must be concise. 2.74. In the year 2005, what is the difference between the Claims(annual growth as % of broad money) of Brazil and Claims(annual growth as % of broad money) of Guatemala?
Provide a short and direct response. 8.61. In the year 2005, what is the difference between the Claims(annual growth as % of broad money) in Brazil and Claims(annual growth as % of broad money) in Vanuatu?
Make the answer very short. 5.04. In the year 2005, what is the difference between the Claims(annual growth as % of broad money) of Comoros and Claims(annual growth as % of broad money) of Guatemala?
Give a very brief answer. 5.87. In the year 2005, what is the difference between the Claims(annual growth as % of broad money) in Comoros and Claims(annual growth as % of broad money) in Vanuatu?
Provide a succinct answer. 2.3. In the year 2005, what is the difference between the Claims(annual growth as % of broad money) in Guatemala and Claims(annual growth as % of broad money) in Vanuatu?
Offer a terse response. -3.57. In the year 2006, what is the difference between the Claims(annual growth as % of broad money) of Brazil and Claims(annual growth as % of broad money) of Comoros?
Your answer should be very brief. 13.75. In the year 2006, what is the difference between the Claims(annual growth as % of broad money) of Brazil and Claims(annual growth as % of broad money) of Guatemala?
Your response must be concise. 0.81. In the year 2006, what is the difference between the Claims(annual growth as % of broad money) of Brazil and Claims(annual growth as % of broad money) of Vanuatu?
Give a very brief answer. 9.66. In the year 2006, what is the difference between the Claims(annual growth as % of broad money) in Comoros and Claims(annual growth as % of broad money) in Guatemala?
Give a very brief answer. -12.94. In the year 2006, what is the difference between the Claims(annual growth as % of broad money) of Comoros and Claims(annual growth as % of broad money) of Vanuatu?
Your response must be concise. -4.09. In the year 2006, what is the difference between the Claims(annual growth as % of broad money) of Guatemala and Claims(annual growth as % of broad money) of Vanuatu?
Provide a succinct answer. 8.85. In the year 2007, what is the difference between the Claims(annual growth as % of broad money) of Brazil and Claims(annual growth as % of broad money) of Comoros?
Your answer should be compact. 14.02. In the year 2007, what is the difference between the Claims(annual growth as % of broad money) in Brazil and Claims(annual growth as % of broad money) in Guatemala?
Your answer should be compact. 10.47. In the year 2007, what is the difference between the Claims(annual growth as % of broad money) of Brazil and Claims(annual growth as % of broad money) of Vanuatu?
Your answer should be compact. 12.86. In the year 2007, what is the difference between the Claims(annual growth as % of broad money) of Comoros and Claims(annual growth as % of broad money) of Guatemala?
Provide a succinct answer. -3.54. In the year 2007, what is the difference between the Claims(annual growth as % of broad money) in Comoros and Claims(annual growth as % of broad money) in Vanuatu?
Provide a succinct answer. -1.16. In the year 2007, what is the difference between the Claims(annual growth as % of broad money) of Guatemala and Claims(annual growth as % of broad money) of Vanuatu?
Offer a terse response. 2.39. In the year 2008, what is the difference between the Claims(annual growth as % of broad money) in Brazil and Claims(annual growth as % of broad money) in Comoros?
Ensure brevity in your answer.  10.24. In the year 2008, what is the difference between the Claims(annual growth as % of broad money) in Brazil and Claims(annual growth as % of broad money) in Guatemala?
Your response must be concise. 13.47. In the year 2008, what is the difference between the Claims(annual growth as % of broad money) in Brazil and Claims(annual growth as % of broad money) in Vanuatu?
Offer a very short reply. 0.88. In the year 2008, what is the difference between the Claims(annual growth as % of broad money) in Comoros and Claims(annual growth as % of broad money) in Guatemala?
Your response must be concise. 3.22. In the year 2008, what is the difference between the Claims(annual growth as % of broad money) of Comoros and Claims(annual growth as % of broad money) of Vanuatu?
Offer a terse response. -9.36. In the year 2008, what is the difference between the Claims(annual growth as % of broad money) in Guatemala and Claims(annual growth as % of broad money) in Vanuatu?
Make the answer very short. -12.59. In the year 2009, what is the difference between the Claims(annual growth as % of broad money) in Brazil and Claims(annual growth as % of broad money) in Comoros?
Make the answer very short. -8.62. In the year 2009, what is the difference between the Claims(annual growth as % of broad money) of Brazil and Claims(annual growth as % of broad money) of Vanuatu?
Ensure brevity in your answer.  -5.16. In the year 2009, what is the difference between the Claims(annual growth as % of broad money) of Comoros and Claims(annual growth as % of broad money) of Vanuatu?
Give a very brief answer. 3.46. In the year 2010, what is the difference between the Claims(annual growth as % of broad money) in Brazil and Claims(annual growth as % of broad money) in Comoros?
Your answer should be compact. 8.31. In the year 2010, what is the difference between the Claims(annual growth as % of broad money) in Brazil and Claims(annual growth as % of broad money) in Guatemala?
Offer a very short reply. 20.02. In the year 2010, what is the difference between the Claims(annual growth as % of broad money) of Brazil and Claims(annual growth as % of broad money) of Vanuatu?
Make the answer very short. 16.06. In the year 2010, what is the difference between the Claims(annual growth as % of broad money) in Comoros and Claims(annual growth as % of broad money) in Guatemala?
Offer a terse response. 11.72. In the year 2010, what is the difference between the Claims(annual growth as % of broad money) of Comoros and Claims(annual growth as % of broad money) of Vanuatu?
Your answer should be compact. 7.75. In the year 2010, what is the difference between the Claims(annual growth as % of broad money) in Guatemala and Claims(annual growth as % of broad money) in Vanuatu?
Provide a succinct answer. -3.97. What is the ratio of the Claims(annual growth as % of broad money) in Brazil in 2003 to that in 2004?
Offer a terse response. 0.42. What is the ratio of the Claims(annual growth as % of broad money) in Guatemala in 2003 to that in 2004?
Make the answer very short. 3.92. What is the ratio of the Claims(annual growth as % of broad money) of Vanuatu in 2003 to that in 2004?
Give a very brief answer. 0.87. What is the ratio of the Claims(annual growth as % of broad money) in Brazil in 2003 to that in 2005?
Your answer should be compact. 0.41. What is the ratio of the Claims(annual growth as % of broad money) of Comoros in 2003 to that in 2005?
Your answer should be very brief. 0.64. What is the ratio of the Claims(annual growth as % of broad money) of Guatemala in 2003 to that in 2005?
Make the answer very short. 6.77. What is the ratio of the Claims(annual growth as % of broad money) in Vanuatu in 2003 to that in 2005?
Your response must be concise. 0.53. What is the ratio of the Claims(annual growth as % of broad money) of Brazil in 2003 to that in 2006?
Make the answer very short. 0.35. What is the ratio of the Claims(annual growth as % of broad money) of Comoros in 2003 to that in 2006?
Give a very brief answer. 31.36. What is the ratio of the Claims(annual growth as % of broad money) of Guatemala in 2003 to that in 2006?
Provide a short and direct response. 1.64. What is the ratio of the Claims(annual growth as % of broad money) of Vanuatu in 2003 to that in 2006?
Your response must be concise. 0.84. What is the ratio of the Claims(annual growth as % of broad money) of Brazil in 2003 to that in 2007?
Offer a very short reply. 0.27. What is the ratio of the Claims(annual growth as % of broad money) of Comoros in 2003 to that in 2007?
Your answer should be compact. 1.3. What is the ratio of the Claims(annual growth as % of broad money) of Guatemala in 2003 to that in 2007?
Your answer should be compact. 2.71. What is the ratio of the Claims(annual growth as % of broad money) in Vanuatu in 2003 to that in 2007?
Your answer should be very brief. 0.64. What is the ratio of the Claims(annual growth as % of broad money) of Brazil in 2003 to that in 2008?
Give a very brief answer. 0.25. What is the ratio of the Claims(annual growth as % of broad money) in Comoros in 2003 to that in 2008?
Offer a very short reply. 0.63. What is the ratio of the Claims(annual growth as % of broad money) in Guatemala in 2003 to that in 2008?
Provide a succinct answer. 3.63. What is the ratio of the Claims(annual growth as % of broad money) of Vanuatu in 2003 to that in 2008?
Offer a terse response. 0.19. What is the ratio of the Claims(annual growth as % of broad money) of Brazil in 2003 to that in 2009?
Provide a short and direct response. 0.59. What is the ratio of the Claims(annual growth as % of broad money) in Comoros in 2003 to that in 2009?
Keep it short and to the point. 0.34. What is the ratio of the Claims(annual growth as % of broad money) in Vanuatu in 2003 to that in 2009?
Provide a short and direct response. 0.27. What is the ratio of the Claims(annual growth as % of broad money) in Brazil in 2003 to that in 2010?
Provide a succinct answer. 0.23. What is the ratio of the Claims(annual growth as % of broad money) in Comoros in 2003 to that in 2010?
Make the answer very short. 0.46. What is the ratio of the Claims(annual growth as % of broad money) of Guatemala in 2003 to that in 2010?
Give a very brief answer. 24.38. What is the ratio of the Claims(annual growth as % of broad money) in Vanuatu in 2003 to that in 2010?
Keep it short and to the point. 0.74. What is the ratio of the Claims(annual growth as % of broad money) in Brazil in 2004 to that in 2005?
Give a very brief answer. 1. What is the ratio of the Claims(annual growth as % of broad money) in Guatemala in 2004 to that in 2005?
Keep it short and to the point. 1.73. What is the ratio of the Claims(annual growth as % of broad money) in Vanuatu in 2004 to that in 2005?
Your answer should be compact. 0.61. What is the ratio of the Claims(annual growth as % of broad money) of Brazil in 2004 to that in 2006?
Keep it short and to the point. 0.85. What is the ratio of the Claims(annual growth as % of broad money) in Guatemala in 2004 to that in 2006?
Offer a terse response. 0.42. What is the ratio of the Claims(annual growth as % of broad money) in Vanuatu in 2004 to that in 2006?
Provide a short and direct response. 0.96. What is the ratio of the Claims(annual growth as % of broad money) in Brazil in 2004 to that in 2007?
Offer a terse response. 0.64. What is the ratio of the Claims(annual growth as % of broad money) of Guatemala in 2004 to that in 2007?
Offer a terse response. 0.69. What is the ratio of the Claims(annual growth as % of broad money) in Vanuatu in 2004 to that in 2007?
Provide a short and direct response. 0.74. What is the ratio of the Claims(annual growth as % of broad money) in Brazil in 2004 to that in 2008?
Offer a terse response. 0.61. What is the ratio of the Claims(annual growth as % of broad money) of Guatemala in 2004 to that in 2008?
Make the answer very short. 0.92. What is the ratio of the Claims(annual growth as % of broad money) in Vanuatu in 2004 to that in 2008?
Your response must be concise. 0.22. What is the ratio of the Claims(annual growth as % of broad money) of Brazil in 2004 to that in 2009?
Your response must be concise. 1.42. What is the ratio of the Claims(annual growth as % of broad money) in Vanuatu in 2004 to that in 2009?
Ensure brevity in your answer.  0.31. What is the ratio of the Claims(annual growth as % of broad money) in Brazil in 2004 to that in 2010?
Offer a terse response. 0.56. What is the ratio of the Claims(annual growth as % of broad money) of Guatemala in 2004 to that in 2010?
Keep it short and to the point. 6.22. What is the ratio of the Claims(annual growth as % of broad money) in Vanuatu in 2004 to that in 2010?
Your response must be concise. 0.85. What is the ratio of the Claims(annual growth as % of broad money) of Brazil in 2005 to that in 2006?
Ensure brevity in your answer.  0.85. What is the ratio of the Claims(annual growth as % of broad money) of Comoros in 2005 to that in 2006?
Your answer should be very brief. 49.38. What is the ratio of the Claims(annual growth as % of broad money) in Guatemala in 2005 to that in 2006?
Keep it short and to the point. 0.24. What is the ratio of the Claims(annual growth as % of broad money) of Vanuatu in 2005 to that in 2006?
Keep it short and to the point. 1.58. What is the ratio of the Claims(annual growth as % of broad money) of Brazil in 2005 to that in 2007?
Your answer should be very brief. 0.64. What is the ratio of the Claims(annual growth as % of broad money) of Comoros in 2005 to that in 2007?
Give a very brief answer. 2.05. What is the ratio of the Claims(annual growth as % of broad money) in Guatemala in 2005 to that in 2007?
Your answer should be compact. 0.4. What is the ratio of the Claims(annual growth as % of broad money) of Vanuatu in 2005 to that in 2007?
Keep it short and to the point. 1.21. What is the ratio of the Claims(annual growth as % of broad money) in Brazil in 2005 to that in 2008?
Ensure brevity in your answer.  0.61. What is the ratio of the Claims(annual growth as % of broad money) of Comoros in 2005 to that in 2008?
Offer a terse response. 0.99. What is the ratio of the Claims(annual growth as % of broad money) in Guatemala in 2005 to that in 2008?
Provide a succinct answer. 0.54. What is the ratio of the Claims(annual growth as % of broad money) in Vanuatu in 2005 to that in 2008?
Your answer should be compact. 0.36. What is the ratio of the Claims(annual growth as % of broad money) in Brazil in 2005 to that in 2009?
Your answer should be compact. 1.42. What is the ratio of the Claims(annual growth as % of broad money) of Comoros in 2005 to that in 2009?
Your response must be concise. 0.54. What is the ratio of the Claims(annual growth as % of broad money) in Vanuatu in 2005 to that in 2009?
Provide a succinct answer. 0.5. What is the ratio of the Claims(annual growth as % of broad money) of Brazil in 2005 to that in 2010?
Your response must be concise. 0.56. What is the ratio of the Claims(annual growth as % of broad money) of Comoros in 2005 to that in 2010?
Your response must be concise. 0.72. What is the ratio of the Claims(annual growth as % of broad money) of Guatemala in 2005 to that in 2010?
Your answer should be very brief. 3.6. What is the ratio of the Claims(annual growth as % of broad money) of Vanuatu in 2005 to that in 2010?
Provide a short and direct response. 1.39. What is the ratio of the Claims(annual growth as % of broad money) in Brazil in 2006 to that in 2007?
Offer a very short reply. 0.76. What is the ratio of the Claims(annual growth as % of broad money) in Comoros in 2006 to that in 2007?
Your response must be concise. 0.04. What is the ratio of the Claims(annual growth as % of broad money) of Guatemala in 2006 to that in 2007?
Offer a terse response. 1.65. What is the ratio of the Claims(annual growth as % of broad money) in Vanuatu in 2006 to that in 2007?
Provide a succinct answer. 0.77. What is the ratio of the Claims(annual growth as % of broad money) of Brazil in 2006 to that in 2008?
Make the answer very short. 0.72. What is the ratio of the Claims(annual growth as % of broad money) of Comoros in 2006 to that in 2008?
Offer a terse response. 0.02. What is the ratio of the Claims(annual growth as % of broad money) in Guatemala in 2006 to that in 2008?
Provide a short and direct response. 2.21. What is the ratio of the Claims(annual growth as % of broad money) of Vanuatu in 2006 to that in 2008?
Your response must be concise. 0.23. What is the ratio of the Claims(annual growth as % of broad money) of Brazil in 2006 to that in 2009?
Ensure brevity in your answer.  1.68. What is the ratio of the Claims(annual growth as % of broad money) in Comoros in 2006 to that in 2009?
Your answer should be very brief. 0.01. What is the ratio of the Claims(annual growth as % of broad money) of Vanuatu in 2006 to that in 2009?
Keep it short and to the point. 0.32. What is the ratio of the Claims(annual growth as % of broad money) of Brazil in 2006 to that in 2010?
Your answer should be compact. 0.67. What is the ratio of the Claims(annual growth as % of broad money) of Comoros in 2006 to that in 2010?
Provide a succinct answer. 0.01. What is the ratio of the Claims(annual growth as % of broad money) of Guatemala in 2006 to that in 2010?
Keep it short and to the point. 14.84. What is the ratio of the Claims(annual growth as % of broad money) in Vanuatu in 2006 to that in 2010?
Make the answer very short. 0.88. What is the ratio of the Claims(annual growth as % of broad money) in Brazil in 2007 to that in 2008?
Offer a terse response. 0.95. What is the ratio of the Claims(annual growth as % of broad money) in Comoros in 2007 to that in 2008?
Your response must be concise. 0.48. What is the ratio of the Claims(annual growth as % of broad money) in Guatemala in 2007 to that in 2008?
Ensure brevity in your answer.  1.34. What is the ratio of the Claims(annual growth as % of broad money) of Vanuatu in 2007 to that in 2008?
Make the answer very short. 0.3. What is the ratio of the Claims(annual growth as % of broad money) in Brazil in 2007 to that in 2009?
Ensure brevity in your answer.  2.22. What is the ratio of the Claims(annual growth as % of broad money) of Comoros in 2007 to that in 2009?
Make the answer very short. 0.26. What is the ratio of the Claims(annual growth as % of broad money) of Vanuatu in 2007 to that in 2009?
Make the answer very short. 0.41. What is the ratio of the Claims(annual growth as % of broad money) in Brazil in 2007 to that in 2010?
Make the answer very short. 0.88. What is the ratio of the Claims(annual growth as % of broad money) of Comoros in 2007 to that in 2010?
Your answer should be compact. 0.35. What is the ratio of the Claims(annual growth as % of broad money) in Guatemala in 2007 to that in 2010?
Ensure brevity in your answer.  8.99. What is the ratio of the Claims(annual growth as % of broad money) in Vanuatu in 2007 to that in 2010?
Provide a short and direct response. 1.15. What is the ratio of the Claims(annual growth as % of broad money) in Brazil in 2008 to that in 2009?
Offer a terse response. 2.34. What is the ratio of the Claims(annual growth as % of broad money) in Comoros in 2008 to that in 2009?
Ensure brevity in your answer.  0.54. What is the ratio of the Claims(annual growth as % of broad money) in Vanuatu in 2008 to that in 2009?
Provide a succinct answer. 1.38. What is the ratio of the Claims(annual growth as % of broad money) in Comoros in 2008 to that in 2010?
Your answer should be compact. 0.73. What is the ratio of the Claims(annual growth as % of broad money) in Guatemala in 2008 to that in 2010?
Your answer should be compact. 6.72. What is the ratio of the Claims(annual growth as % of broad money) of Vanuatu in 2008 to that in 2010?
Your response must be concise. 3.82. What is the ratio of the Claims(annual growth as % of broad money) in Brazil in 2009 to that in 2010?
Your response must be concise. 0.4. What is the ratio of the Claims(annual growth as % of broad money) in Comoros in 2009 to that in 2010?
Your answer should be very brief. 1.34. What is the ratio of the Claims(annual growth as % of broad money) of Vanuatu in 2009 to that in 2010?
Offer a terse response. 2.77. What is the difference between the highest and the second highest Claims(annual growth as % of broad money) in Brazil?
Make the answer very short. 1.49. What is the difference between the highest and the second highest Claims(annual growth as % of broad money) of Comoros?
Give a very brief answer. 4.3. What is the difference between the highest and the second highest Claims(annual growth as % of broad money) in Guatemala?
Make the answer very short. 8.44. What is the difference between the highest and the second highest Claims(annual growth as % of broad money) of Vanuatu?
Ensure brevity in your answer.  5.09. What is the difference between the highest and the lowest Claims(annual growth as % of broad money) of Brazil?
Your answer should be very brief. 16.01. What is the difference between the highest and the lowest Claims(annual growth as % of broad money) of Comoros?
Keep it short and to the point. 16.91. What is the difference between the highest and the lowest Claims(annual growth as % of broad money) of Guatemala?
Your answer should be compact. 21.57. What is the difference between the highest and the lowest Claims(annual growth as % of broad money) of Vanuatu?
Your response must be concise. 14.96. 